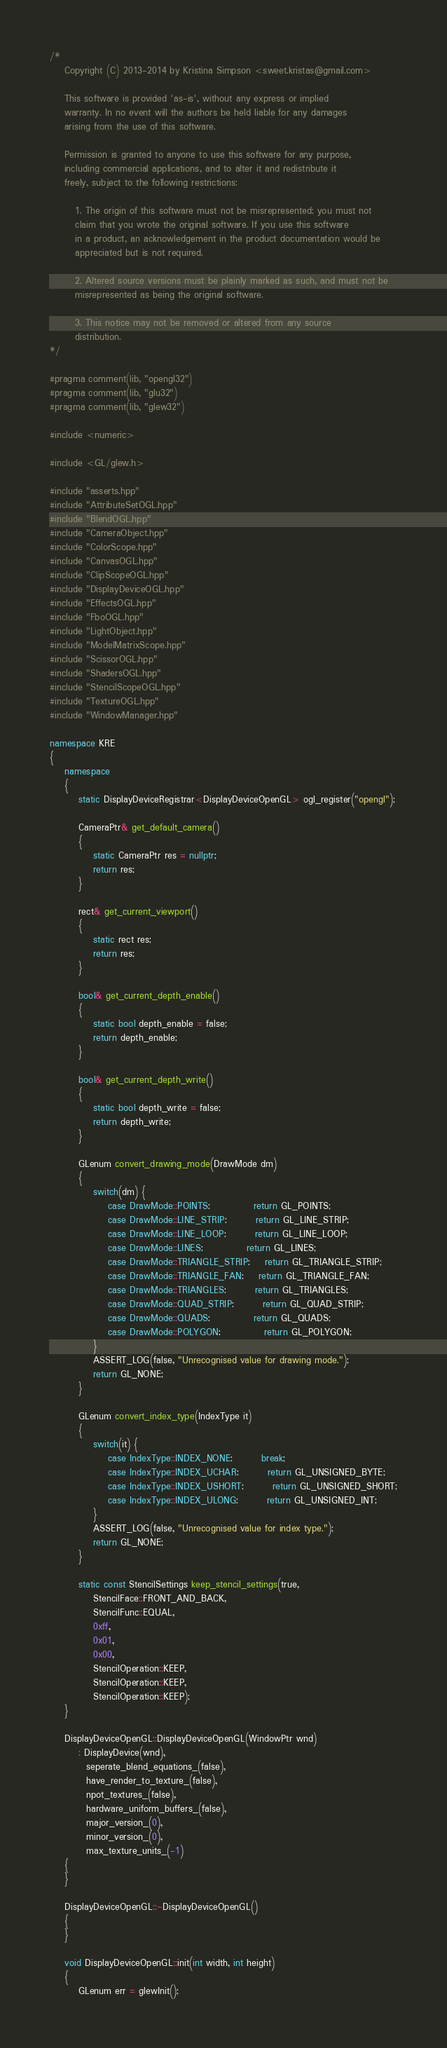Convert code to text. <code><loc_0><loc_0><loc_500><loc_500><_C++_>/*
	Copyright (C) 2013-2014 by Kristina Simpson <sweet.kristas@gmail.com>
	
	This software is provided 'as-is', without any express or implied
	warranty. In no event will the authors be held liable for any damages
	arising from the use of this software.

	Permission is granted to anyone to use this software for any purpose,
	including commercial applications, and to alter it and redistribute it
	freely, subject to the following restrictions:

	   1. The origin of this software must not be misrepresented; you must not
	   claim that you wrote the original software. If you use this software
	   in a product, an acknowledgement in the product documentation would be
	   appreciated but is not required.

	   2. Altered source versions must be plainly marked as such, and must not be
	   misrepresented as being the original software.

	   3. This notice may not be removed or altered from any source
	   distribution.
*/

#pragma comment(lib, "opengl32")
#pragma comment(lib, "glu32")
#pragma comment(lib, "glew32")

#include <numeric>

#include <GL/glew.h>

#include "asserts.hpp"
#include "AttributeSetOGL.hpp"
#include "BlendOGL.hpp"
#include "CameraObject.hpp"
#include "ColorScope.hpp"
#include "CanvasOGL.hpp"
#include "ClipScopeOGL.hpp"
#include "DisplayDeviceOGL.hpp"
#include "EffectsOGL.hpp"
#include "FboOGL.hpp"
#include "LightObject.hpp"
#include "ModelMatrixScope.hpp"
#include "ScissorOGL.hpp"
#include "ShadersOGL.hpp"
#include "StencilScopeOGL.hpp"
#include "TextureOGL.hpp"
#include "WindowManager.hpp"

namespace KRE
{
	namespace
	{
		static DisplayDeviceRegistrar<DisplayDeviceOpenGL> ogl_register("opengl");

		CameraPtr& get_default_camera()
		{
			static CameraPtr res = nullptr;
			return res;
		}

		rect& get_current_viewport()
		{
			static rect res;
			return res;
		}

		bool& get_current_depth_enable()
		{
			static bool depth_enable = false;
			return depth_enable;
		}

		bool& get_current_depth_write()
		{
			static bool depth_write = false;
			return depth_write;
		}

		GLenum convert_drawing_mode(DrawMode dm)
		{
			switch(dm) {
				case DrawMode::POINTS:			return GL_POINTS;
				case DrawMode::LINE_STRIP:		return GL_LINE_STRIP;
				case DrawMode::LINE_LOOP:		return GL_LINE_LOOP;
				case DrawMode::LINES:			return GL_LINES;
				case DrawMode::TRIANGLE_STRIP:	return GL_TRIANGLE_STRIP;
				case DrawMode::TRIANGLE_FAN:	return GL_TRIANGLE_FAN;
				case DrawMode::TRIANGLES:		return GL_TRIANGLES;
				case DrawMode::QUAD_STRIP:		return GL_QUAD_STRIP;
				case DrawMode::QUADS:			return GL_QUADS;
				case DrawMode::POLYGON:			return GL_POLYGON;
			}
			ASSERT_LOG(false, "Unrecognised value for drawing mode.");
			return GL_NONE;
		}

		GLenum convert_index_type(IndexType it) 
		{
			switch(it) {
				case IndexType::INDEX_NONE:		break;
				case IndexType::INDEX_UCHAR:		return GL_UNSIGNED_BYTE;
				case IndexType::INDEX_USHORT:		return GL_UNSIGNED_SHORT;
				case IndexType::INDEX_ULONG:		return GL_UNSIGNED_INT;
			}
			ASSERT_LOG(false, "Unrecognised value for index type.");
			return GL_NONE;
		}

		static const StencilSettings keep_stencil_settings(true,
			StencilFace::FRONT_AND_BACK, 
			StencilFunc::EQUAL, 
			0xff,
			0x01,
			0x00,
			StencilOperation::KEEP,
			StencilOperation::KEEP,
			StencilOperation::KEEP);
	}

	DisplayDeviceOpenGL::DisplayDeviceOpenGL(WindowPtr wnd)
		: DisplayDevice(wnd),
		  seperate_blend_equations_(false),
		  have_render_to_texture_(false),
		  npot_textures_(false),
		  hardware_uniform_buffers_(false),
		  major_version_(0),
		  minor_version_(0),
		  max_texture_units_(-1)
	{
	}

	DisplayDeviceOpenGL::~DisplayDeviceOpenGL()
	{
	}

	void DisplayDeviceOpenGL::init(int width, int height)
	{
		GLenum err = glewInit();</code> 